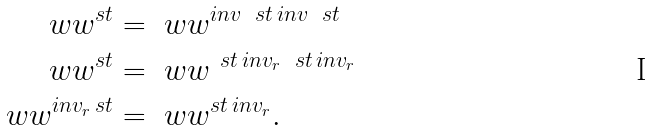<formula> <loc_0><loc_0><loc_500><loc_500>\ w w ^ { s t } & = \ w w ^ { i n v \, \ s t \, i n v \, \ s t } \\ \ w w ^ { s t } & = \ w w ^ { \ s t \, i n v _ { r } \, \ s t \, i n v _ { r } } \\ \ w w ^ { i n v _ { r } \, s t } & = \ w w ^ { s t \, i n v _ { r } } .</formula> 